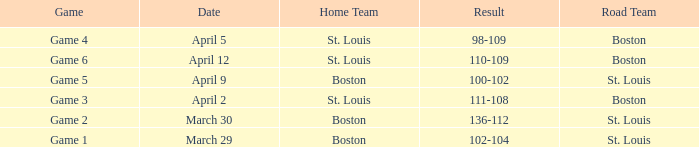On what Date is Game 3 with Boston Road Team? April 2. 